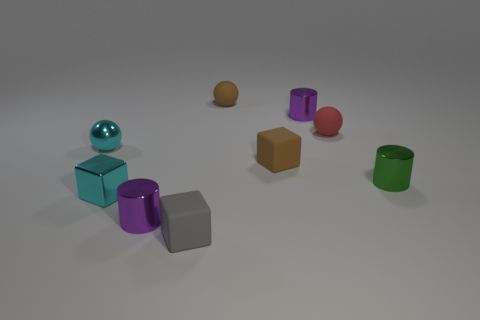Subtract all cyan balls. How many balls are left? 2 Subtract all brown cubes. How many cubes are left? 2 Subtract all blocks. How many objects are left? 6 Subtract 1 balls. How many balls are left? 2 Add 1 green metallic cylinders. How many objects exist? 10 Subtract all green cylinders. How many brown spheres are left? 1 Subtract all balls. Subtract all small red matte objects. How many objects are left? 5 Add 5 brown spheres. How many brown spheres are left? 6 Add 8 small gray rubber spheres. How many small gray rubber spheres exist? 8 Subtract 1 green cylinders. How many objects are left? 8 